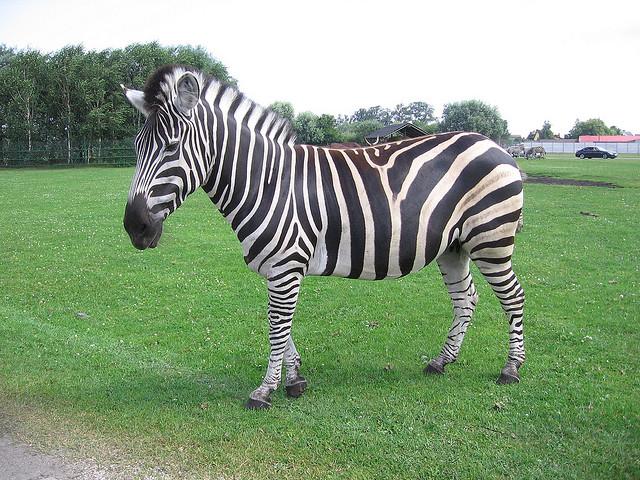Is the zebra standing in its native habitat?
Give a very brief answer. No. What do you think the Zebra is thinking?
Be succinct. Food. Is the animal laying in grass?
Short answer required. No. How many stripes are on the zebra?
Answer briefly. Many. Is the zebra eating?
Quick response, please. No. Where do zebras live?
Keep it brief. Africa. 